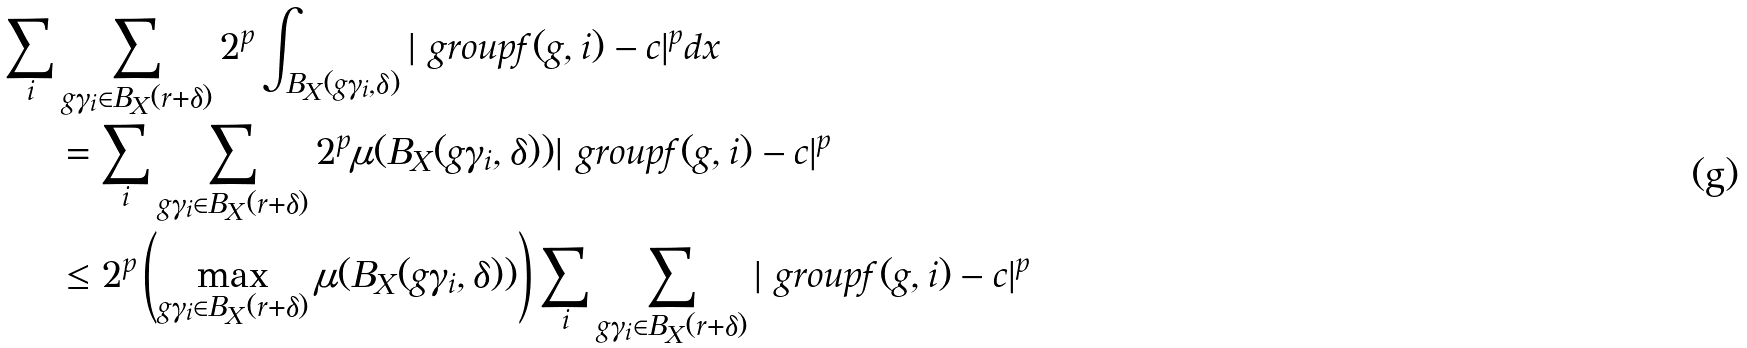Convert formula to latex. <formula><loc_0><loc_0><loc_500><loc_500>\sum _ { i } & \sum _ { g \gamma _ { i } \in B _ { X } ( r + \delta ) } 2 ^ { p } \int _ { B _ { X } ( g \gamma _ { i } , \delta ) } | \ g r o u p { f ( g , i ) } - c | ^ { p } d x \\ & = \sum _ { i } \sum _ { g \gamma _ { i } \in B _ { X } ( r + \delta ) } 2 ^ { p } \mu ( B _ { X } ( g \gamma _ { i } , \delta ) ) | \ g r o u p { f ( g , i ) } - c | ^ { p } \\ & \leq 2 ^ { p } \left ( \max _ { g \gamma _ { i } \in B _ { X } ( r + \delta ) } \mu ( B _ { X } ( g \gamma _ { i } , \delta ) ) \right ) \sum _ { i } \sum _ { g \gamma _ { i } \in B _ { X } ( r + \delta ) } | \ g r o u p { f ( g , i ) } - c | ^ { p }</formula> 